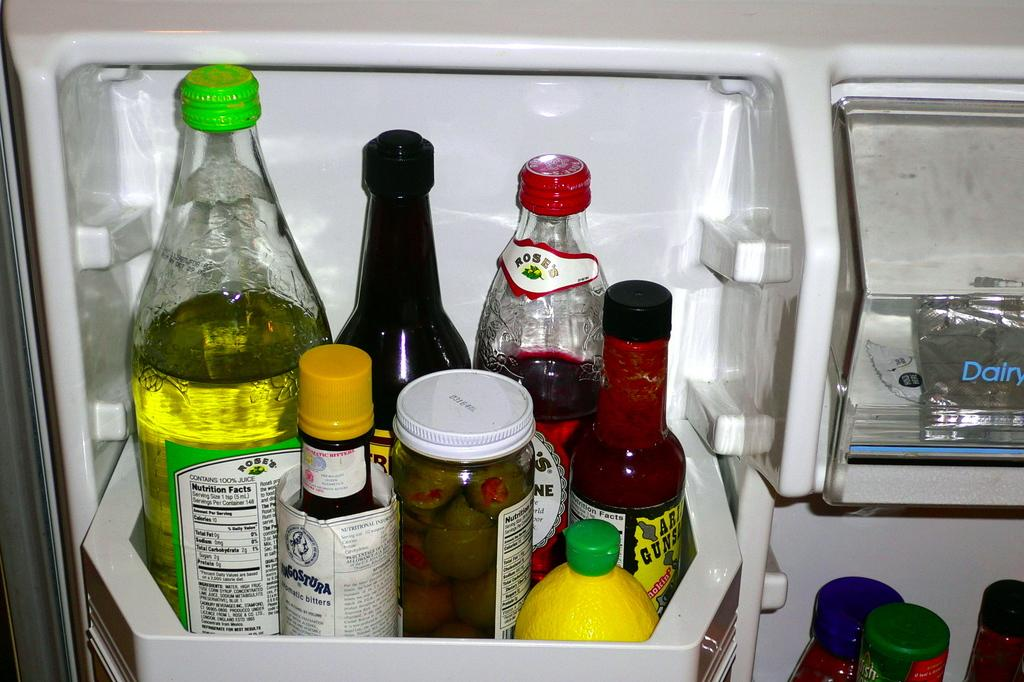What objects in the image have stickers on them? There are bottles with stickers in the image. How are the bottles arranged in the image? The bottles are in a rack. Where is the rack located in the image? The rack is inside a fridge or refrigerator. What type of game is being played on the crib in the image? There is no crib or game present in the image; it features bottles with stickers in a rack inside a fridge or refrigerator. 